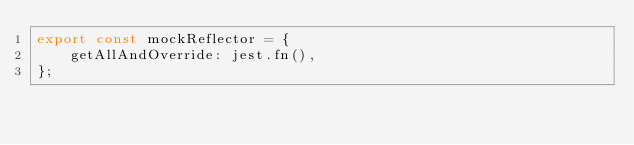Convert code to text. <code><loc_0><loc_0><loc_500><loc_500><_TypeScript_>export const mockReflector = {
    getAllAndOverride: jest.fn(),
};
</code> 